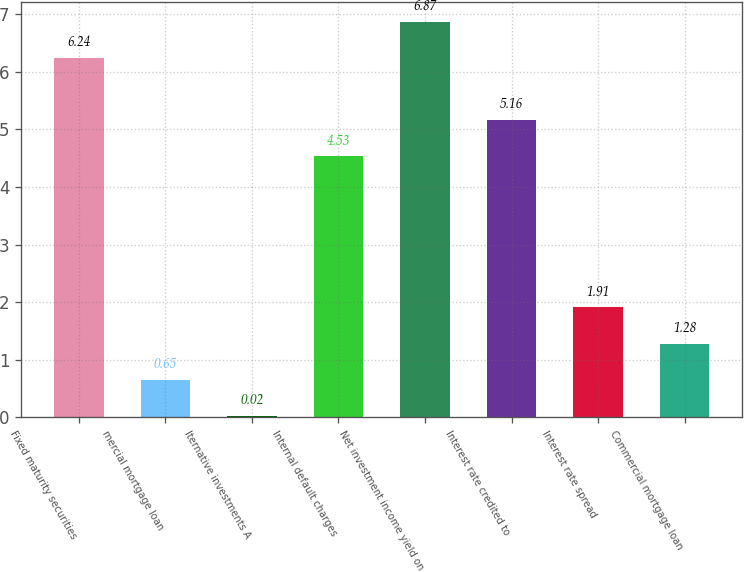Convert chart to OTSL. <chart><loc_0><loc_0><loc_500><loc_500><bar_chart><fcel>Fixed maturity securities<fcel>mercial mortgage loan<fcel>lternative investments A<fcel>Internal default charges<fcel>Net investment income yield on<fcel>Interest rate credited to<fcel>Interest rate spread<fcel>Commercial mortgage loan<nl><fcel>6.24<fcel>0.65<fcel>0.02<fcel>4.53<fcel>6.87<fcel>5.16<fcel>1.91<fcel>1.28<nl></chart> 